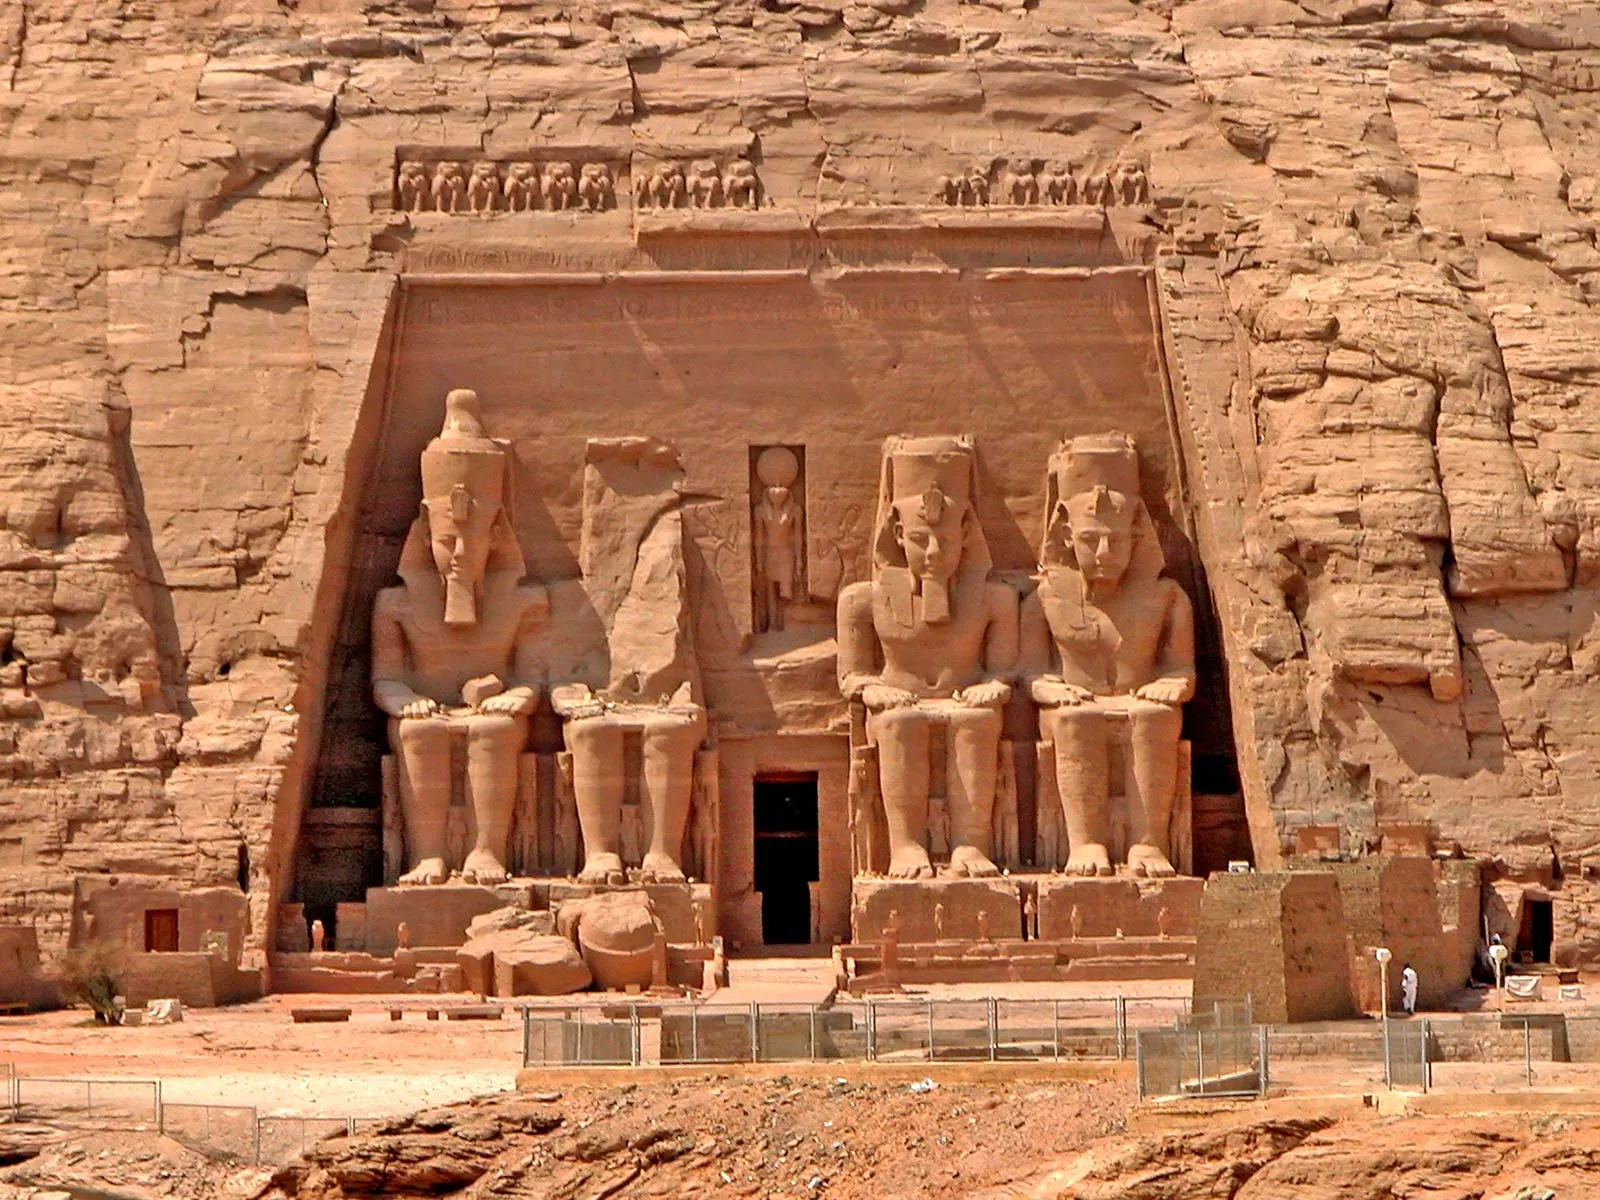How would you describe the feel and atmosphere of the temple from a tourist's perspective? From a tourist's perspective, the feel and atmosphere of the Abu Simbel temple is both awe-inspiring and humbling. As you approach the towering statues, you feel a sense of stepping back in time, surrounded by the enigmatic allure of ancient Egypt. The sheer scale and magnificence of the temple evoke a profound admiration for the ingenuity and craftsmanship that achieved such a feat. The warmth of the sun-baked sandstone, contrasted against the cool shade inside the temple, adds to the sensory experience. The quiet stillness of the interior, away from the bustling crowds, allows for moments of introspection and connection with history. The distant sound of the wind and the faint whispers of tour guides blend into a symphony of reverence. As you explore, the intricate details of the carvings and hieroglyphs, illuminated by the soft glow of strategically placed lights, reveal stories of a bygone era. It is a journey of discovery, not just through a historical site, but through the soul of an ancient civilization. 